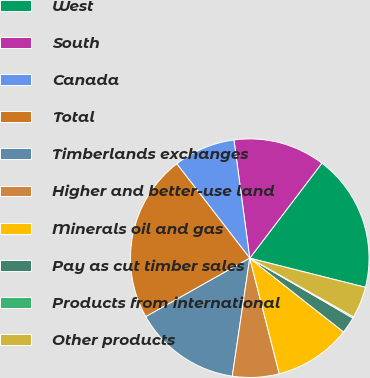Convert chart to OTSL. <chart><loc_0><loc_0><loc_500><loc_500><pie_chart><fcel>West<fcel>South<fcel>Canada<fcel>Total<fcel>Timberlands exchanges<fcel>Higher and better-use land<fcel>Minerals oil and gas<fcel>Pay as cut timber sales<fcel>Products from international<fcel>Other products<nl><fcel>18.59%<fcel>12.45%<fcel>8.36%<fcel>22.68%<fcel>14.5%<fcel>6.32%<fcel>10.41%<fcel>2.23%<fcel>0.18%<fcel>4.27%<nl></chart> 